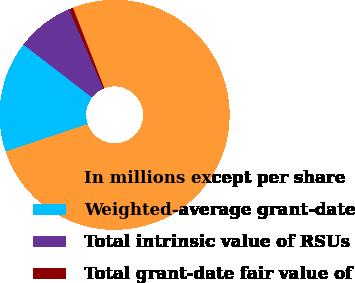Convert chart to OTSL. <chart><loc_0><loc_0><loc_500><loc_500><pie_chart><fcel>In millions except per share<fcel>Weighted-average grant-date<fcel>Total intrinsic value of RSUs<fcel>Total grant-date fair value of<nl><fcel>75.77%<fcel>15.6%<fcel>8.08%<fcel>0.56%<nl></chart> 